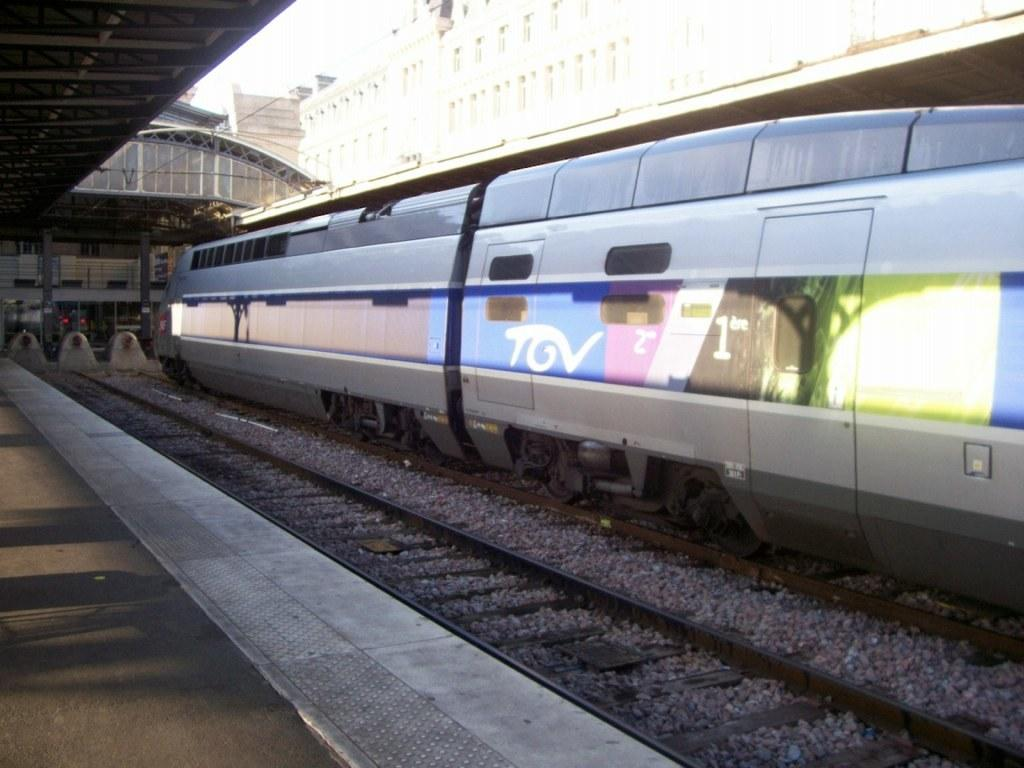<image>
Provide a brief description of the given image. The train at the station has the lettering TGV on the side of it. 